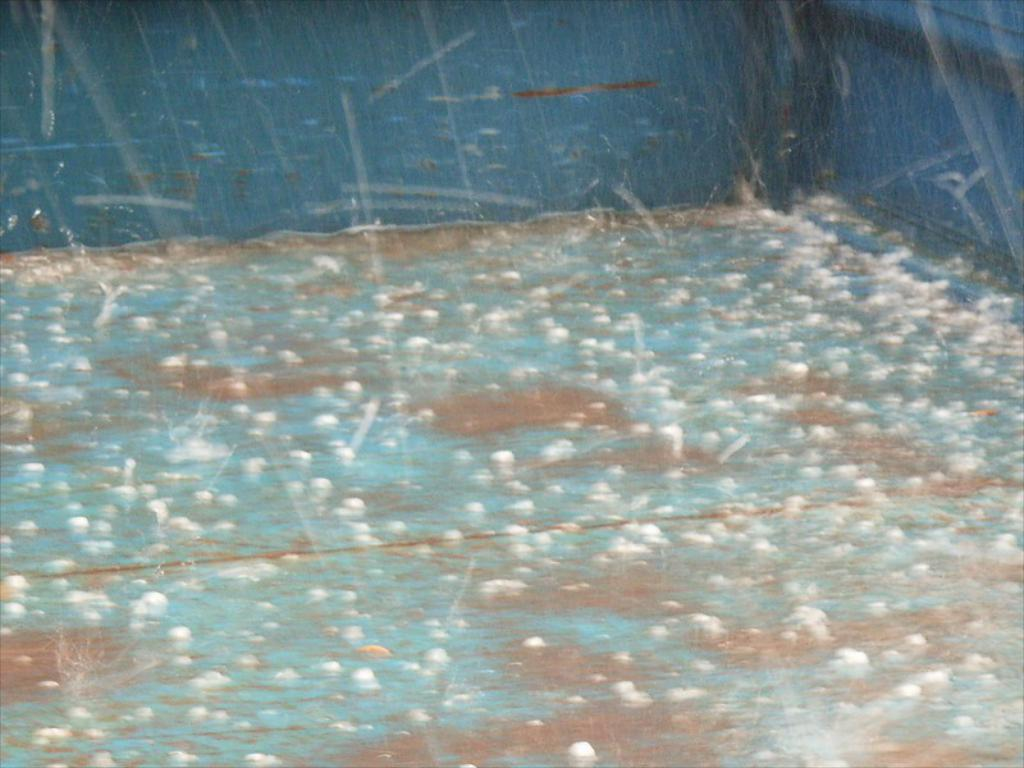What is happening to the surface in the image? Raindrops are falling on a surface in the image. What can be found on the floor in the image? There are ice pieces on the floor in the image. What color is the surface visible in the background of the image? The surface visible in the background of the image is blue. What type of pies are being baked in the image? There are no pies present in the image; it features raindrops falling on a surface and ice pieces on the floor. 